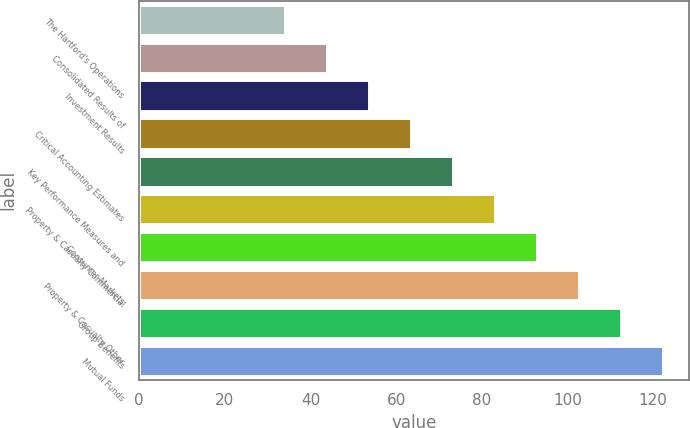Convert chart to OTSL. <chart><loc_0><loc_0><loc_500><loc_500><bar_chart><fcel>The Hartford's Operations<fcel>Consolidated Results of<fcel>Investment Results<fcel>Critical Accounting Estimates<fcel>Key Performance Measures and<fcel>Property & Casualty Commercial<fcel>Consumer Markets<fcel>Property & Casualty Other<fcel>Group Benefits<fcel>Mutual Funds<nl><fcel>34<fcel>43.8<fcel>53.6<fcel>63.4<fcel>73.2<fcel>83<fcel>92.8<fcel>102.6<fcel>112.4<fcel>122.2<nl></chart> 